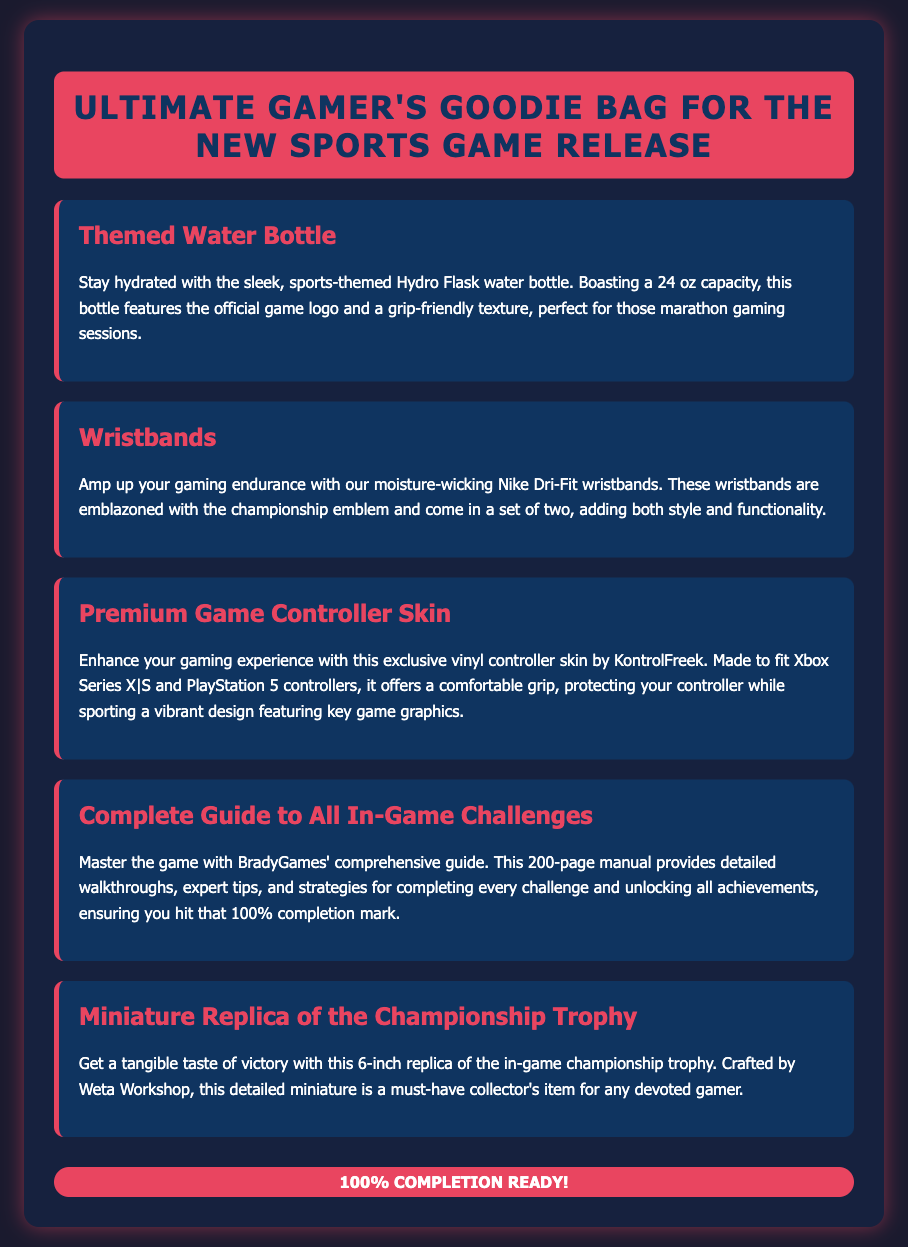What is included in the Ultimate Gamer's Goodie Bag? The document lists the items included in the Goodie Bag: a themed water bottle, wristbands, a premium game controller skin, a complete guide to all in-game challenges, and a miniature replica of the championship trophy.
Answer: Themed water bottle, wristbands, premium game controller skin, complete guide, miniature trophy What is the capacity of the themed water bottle? The themed water bottle has a capacity of 24 oz, as mentioned in the description.
Answer: 24 oz What type of wristbands are included? The wristbands are described as moisture-wicking Nike Dri-Fit wristbands.
Answer: Nike Dri-Fit How many pages does the complete guide have? It is stated that the complete guide consists of a total of 200 pages.
Answer: 200 pages What is the size of the miniature replica of the championship trophy? The miniature trophy is specified to be 6 inches in size.
Answer: 6 inches What purpose does the premium game controller skin serve? The premium game controller skin enhances the gaming experience by providing a comfortable grip and protecting the controller.
Answer: Comfortable grip and protection Why is the complete guide significant for gamers? The complete guide is significant as it provides detailed walkthroughs and strategies to help achieve 100% completion.
Answer: Achieving 100% completion What kind of item is the championship trophy replica described as? The championship trophy replica is described as a detailed miniature and a collector's item.
Answer: Collector's item 